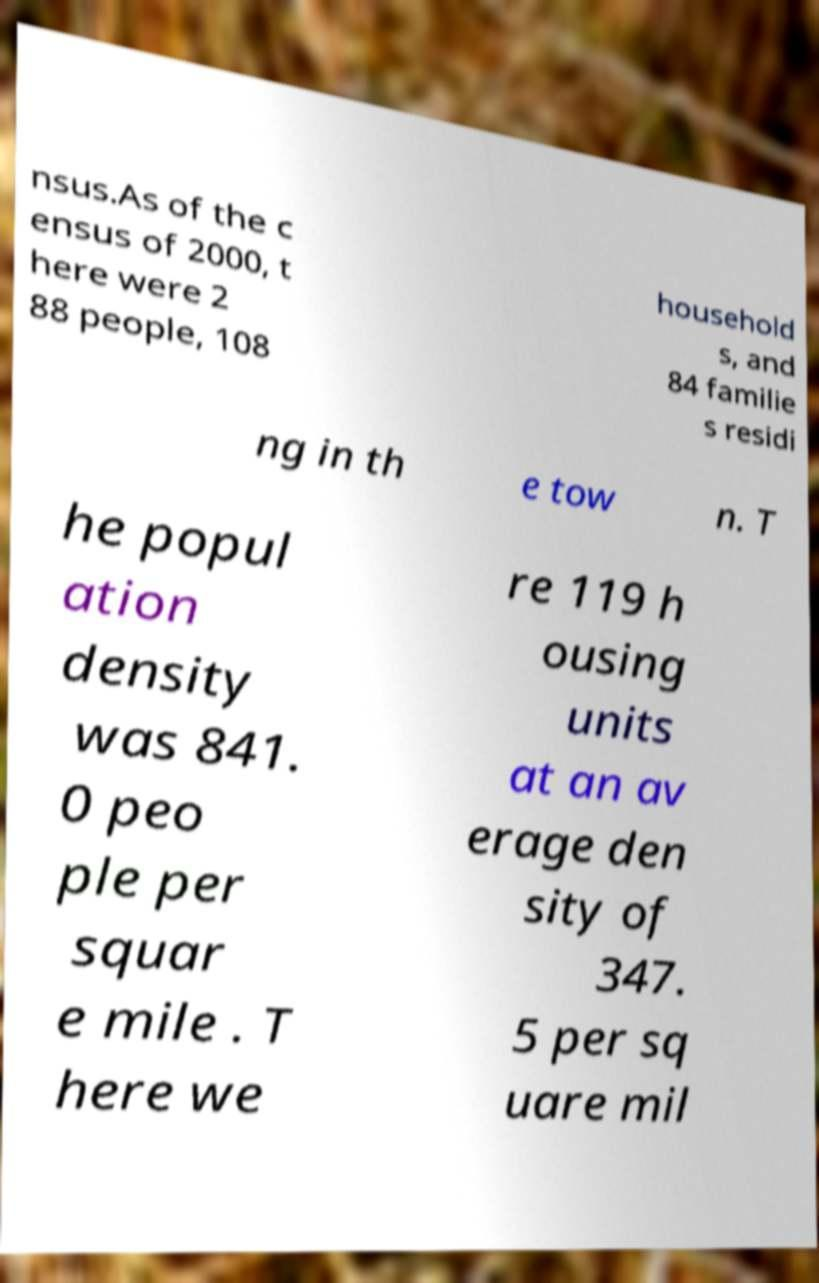There's text embedded in this image that I need extracted. Can you transcribe it verbatim? nsus.As of the c ensus of 2000, t here were 2 88 people, 108 household s, and 84 familie s residi ng in th e tow n. T he popul ation density was 841. 0 peo ple per squar e mile . T here we re 119 h ousing units at an av erage den sity of 347. 5 per sq uare mil 